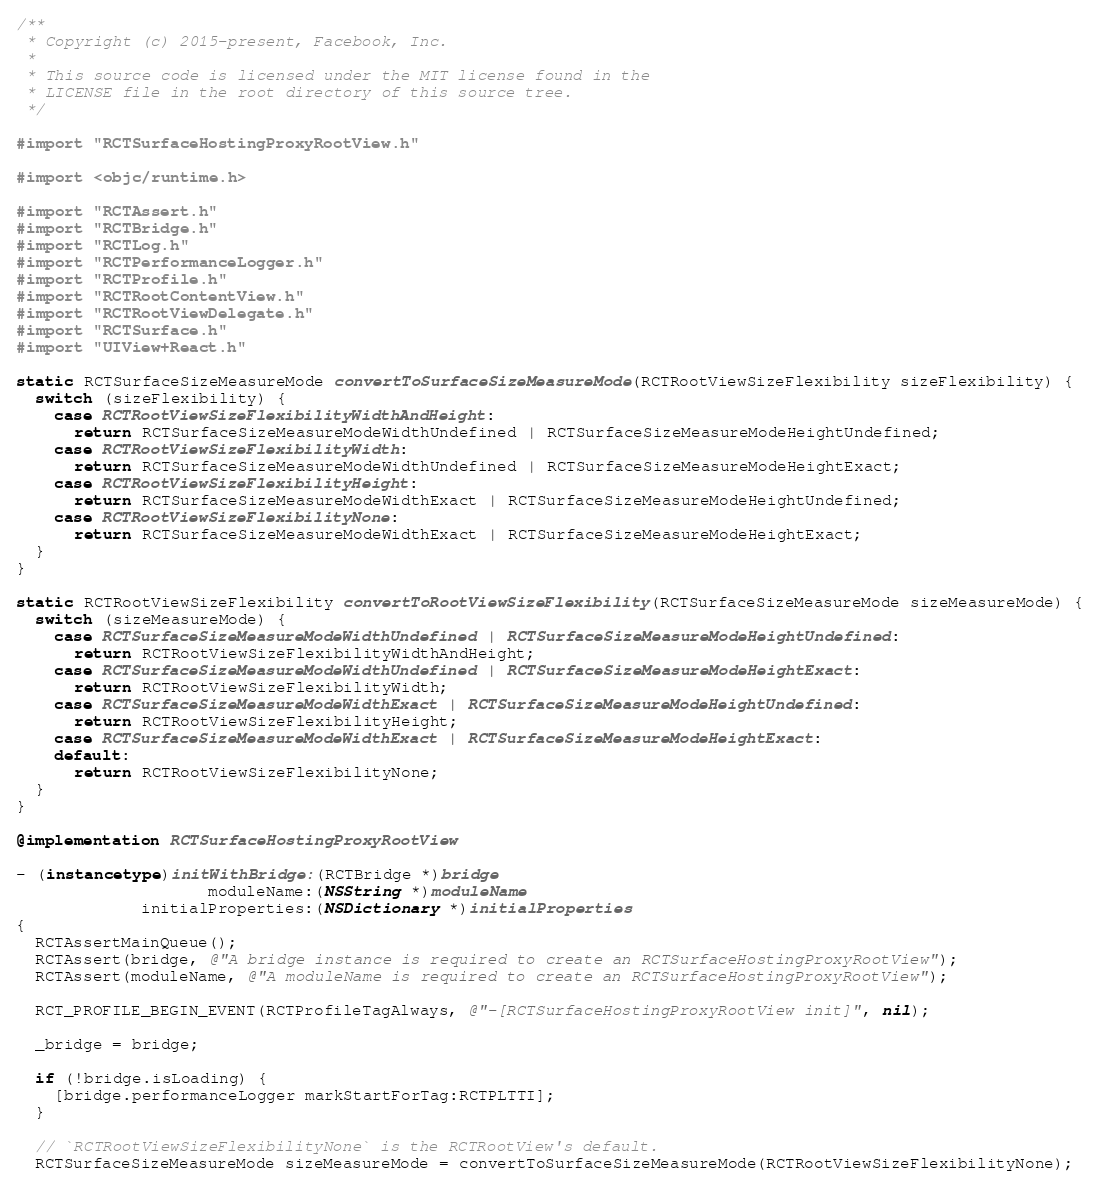Convert code to text. <code><loc_0><loc_0><loc_500><loc_500><_ObjectiveC_>/**
 * Copyright (c) 2015-present, Facebook, Inc.
 *
 * This source code is licensed under the MIT license found in the
 * LICENSE file in the root directory of this source tree.
 */

#import "RCTSurfaceHostingProxyRootView.h"

#import <objc/runtime.h>

#import "RCTAssert.h"
#import "RCTBridge.h"
#import "RCTLog.h"
#import "RCTPerformanceLogger.h"
#import "RCTProfile.h"
#import "RCTRootContentView.h"
#import "RCTRootViewDelegate.h"
#import "RCTSurface.h"
#import "UIView+React.h"

static RCTSurfaceSizeMeasureMode convertToSurfaceSizeMeasureMode(RCTRootViewSizeFlexibility sizeFlexibility) {
  switch (sizeFlexibility) {
    case RCTRootViewSizeFlexibilityWidthAndHeight:
      return RCTSurfaceSizeMeasureModeWidthUndefined | RCTSurfaceSizeMeasureModeHeightUndefined;
    case RCTRootViewSizeFlexibilityWidth:
      return RCTSurfaceSizeMeasureModeWidthUndefined | RCTSurfaceSizeMeasureModeHeightExact;
    case RCTRootViewSizeFlexibilityHeight:
      return RCTSurfaceSizeMeasureModeWidthExact | RCTSurfaceSizeMeasureModeHeightUndefined;
    case RCTRootViewSizeFlexibilityNone:
      return RCTSurfaceSizeMeasureModeWidthExact | RCTSurfaceSizeMeasureModeHeightExact;
  }
}

static RCTRootViewSizeFlexibility convertToRootViewSizeFlexibility(RCTSurfaceSizeMeasureMode sizeMeasureMode) {
  switch (sizeMeasureMode) {
    case RCTSurfaceSizeMeasureModeWidthUndefined | RCTSurfaceSizeMeasureModeHeightUndefined:
      return RCTRootViewSizeFlexibilityWidthAndHeight;
    case RCTSurfaceSizeMeasureModeWidthUndefined | RCTSurfaceSizeMeasureModeHeightExact:
      return RCTRootViewSizeFlexibilityWidth;
    case RCTSurfaceSizeMeasureModeWidthExact | RCTSurfaceSizeMeasureModeHeightUndefined:
      return RCTRootViewSizeFlexibilityHeight;
    case RCTSurfaceSizeMeasureModeWidthExact | RCTSurfaceSizeMeasureModeHeightExact:
    default:
      return RCTRootViewSizeFlexibilityNone;
  }
}

@implementation RCTSurfaceHostingProxyRootView

- (instancetype)initWithBridge:(RCTBridge *)bridge
                    moduleName:(NSString *)moduleName
             initialProperties:(NSDictionary *)initialProperties
{
  RCTAssertMainQueue();
  RCTAssert(bridge, @"A bridge instance is required to create an RCTSurfaceHostingProxyRootView");
  RCTAssert(moduleName, @"A moduleName is required to create an RCTSurfaceHostingProxyRootView");

  RCT_PROFILE_BEGIN_EVENT(RCTProfileTagAlways, @"-[RCTSurfaceHostingProxyRootView init]", nil);

  _bridge = bridge;

  if (!bridge.isLoading) {
    [bridge.performanceLogger markStartForTag:RCTPLTTI];
  }

  // `RCTRootViewSizeFlexibilityNone` is the RCTRootView's default.
  RCTSurfaceSizeMeasureMode sizeMeasureMode = convertToSurfaceSizeMeasureMode(RCTRootViewSizeFlexibilityNone);
</code> 